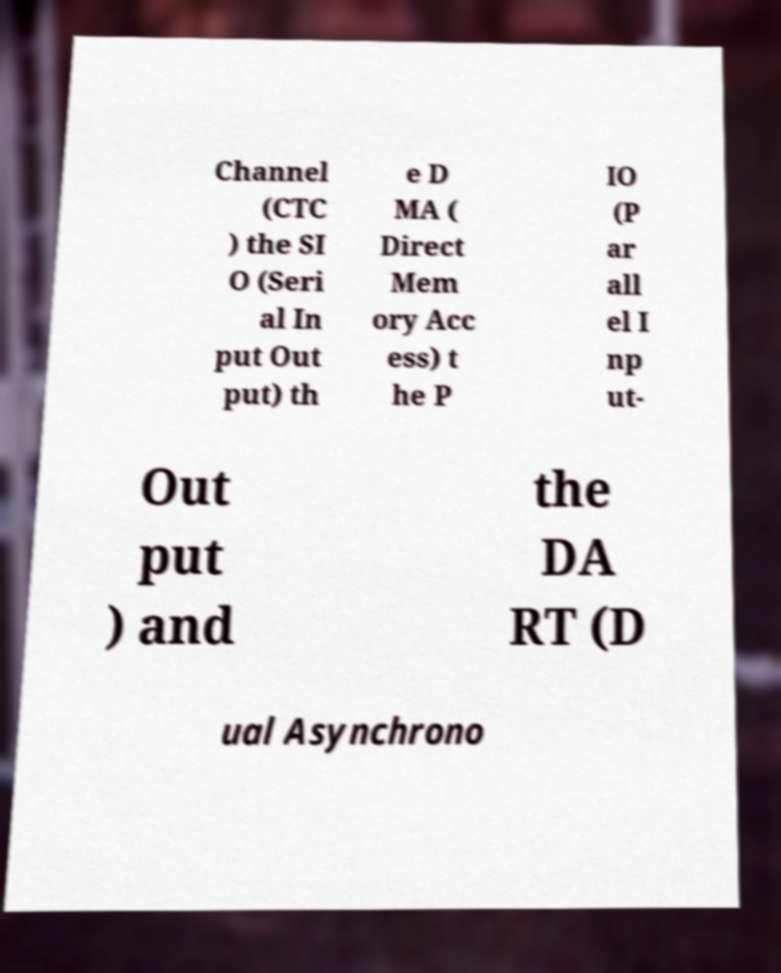There's text embedded in this image that I need extracted. Can you transcribe it verbatim? Channel (CTC ) the SI O (Seri al In put Out put) th e D MA ( Direct Mem ory Acc ess) t he P IO (P ar all el I np ut- Out put ) and the DA RT (D ual Asynchrono 